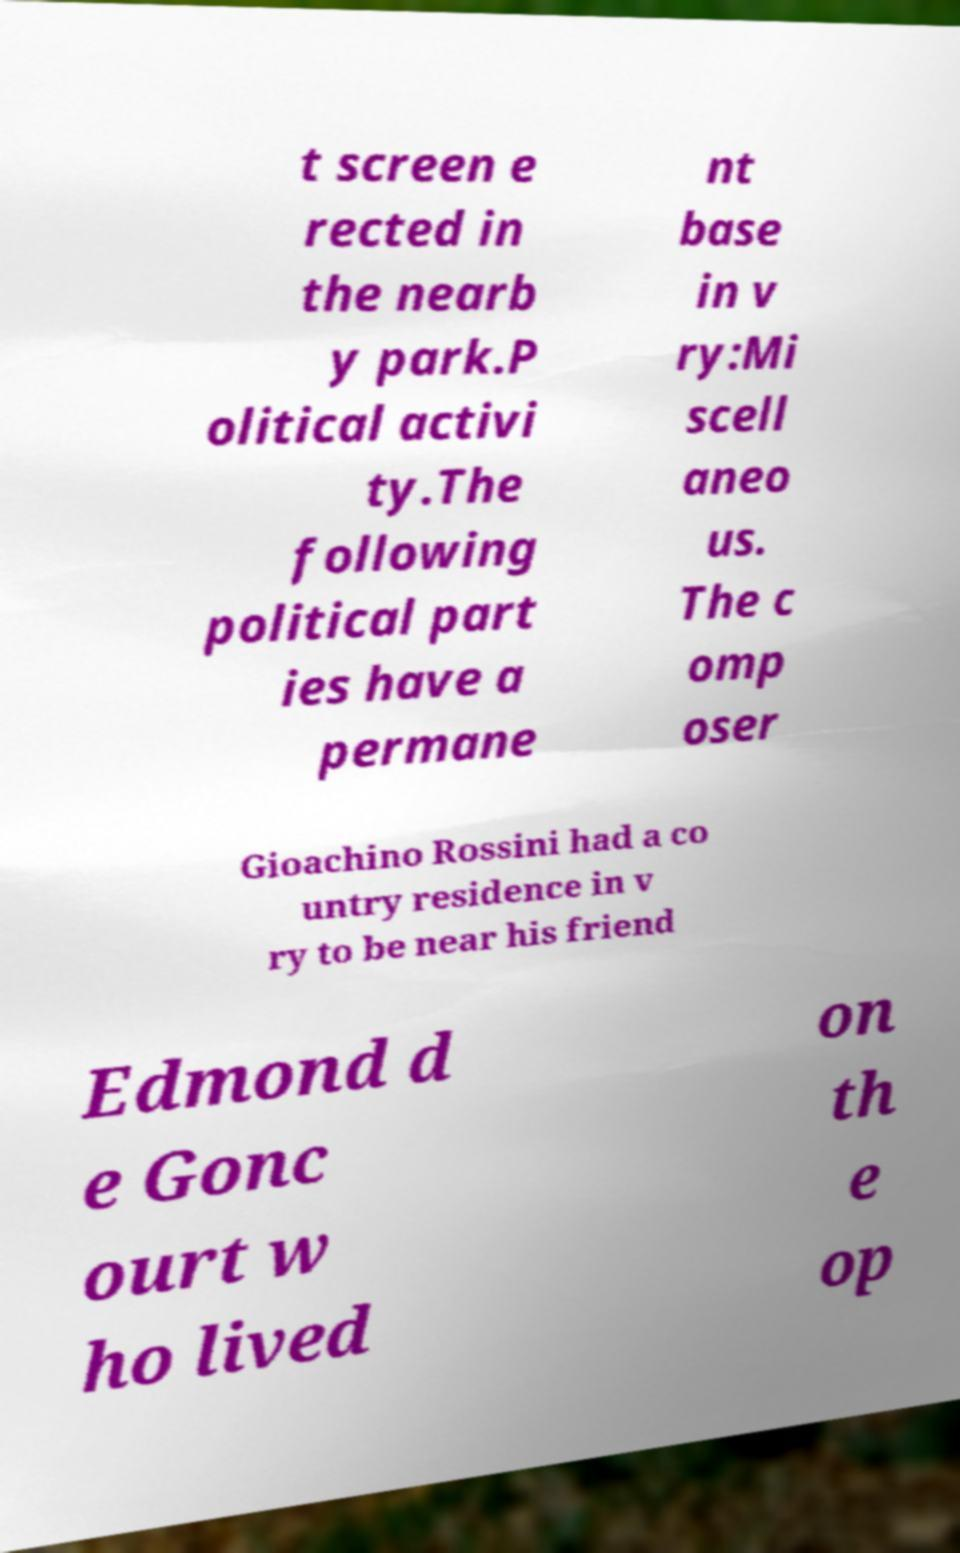Please identify and transcribe the text found in this image. t screen e rected in the nearb y park.P olitical activi ty.The following political part ies have a permane nt base in v ry:Mi scell aneo us. The c omp oser Gioachino Rossini had a co untry residence in v ry to be near his friend Edmond d e Gonc ourt w ho lived on th e op 